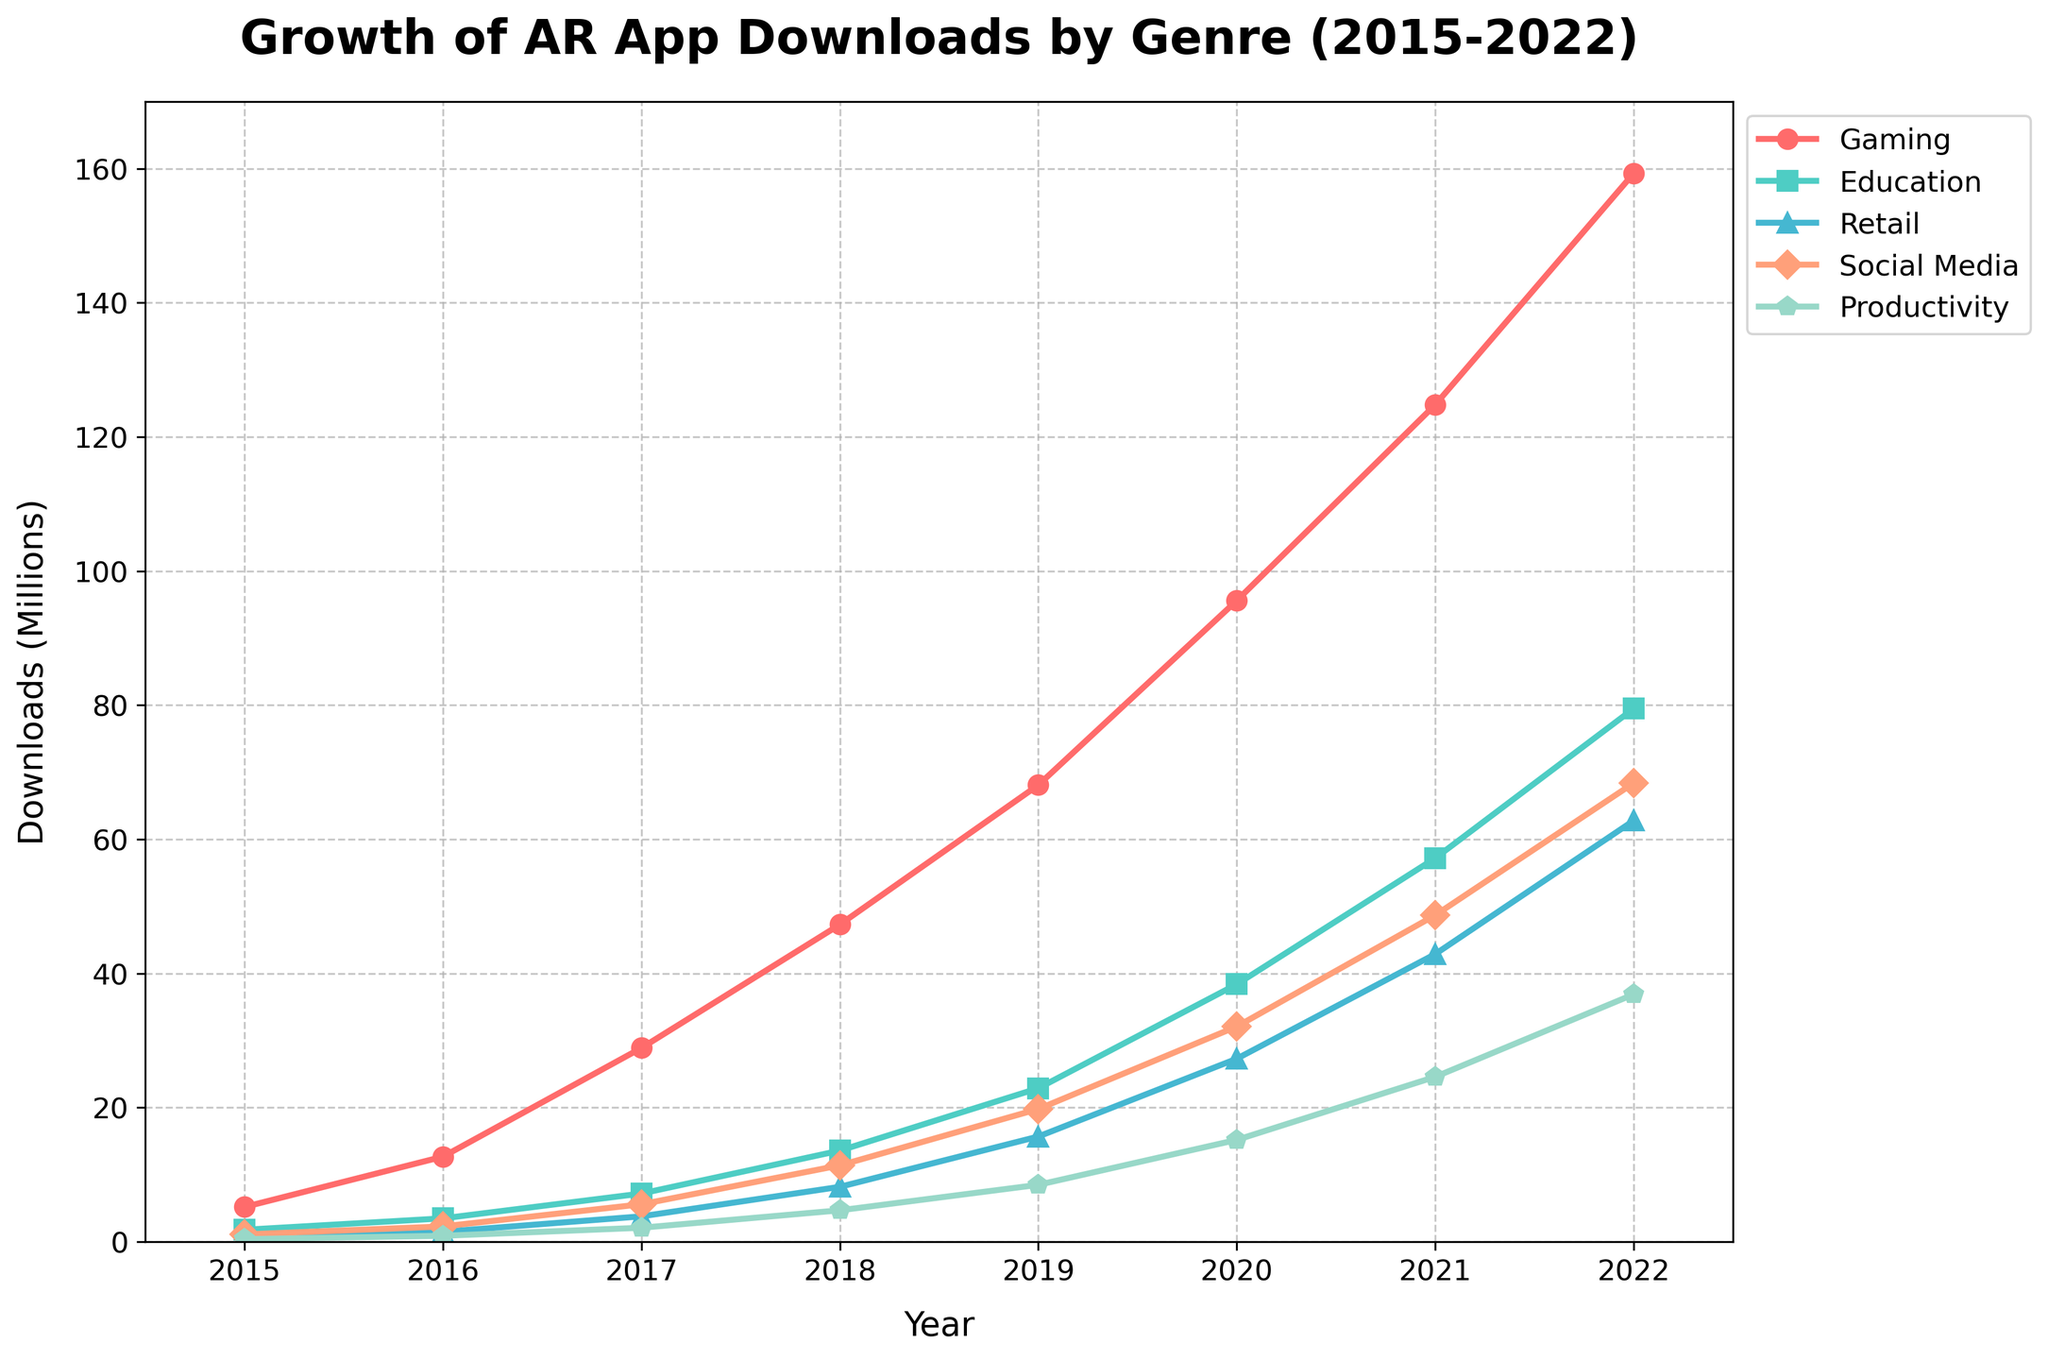What's the total number of downloads for all genres in 2017? To find the total number of downloads for all genres in 2017, sum the values for Gaming, Education, Retail, Social Media, and Productivity. So, 28.9 + 7.2 + 3.8 + 5.6 + 2.1 = 47.6 million.
Answer: 47.6 million Which genre saw the highest downloads in 2022? Examine the values for each genre in 2022: Gaming (159.3), Education (79.5), Retail (62.8), Social Media (68.4), and Productivity (36.9). The highest value is Gaming with 159.3 million downloads.
Answer: Gaming In which year did Social Media surpass 30 million downloads? Analyze the trend line of Social Media and find the year it first surpasses 30 million. It occurs in 2020 where it reaches 32.1 million downloads.
Answer: 2020 How much more did Gaming downloads grow compared to Retail from 2015 to 2022? Calculate the difference in growth for both genres from 2015 to 2022. For Gaming: 159.3 - 5.2 = 154.1. For Retail: 62.8 - 0.7 = 62.1. The growth difference is 154.1 - 62.1 = 92 million.
Answer: 92 million What is the average annual growth of downloads for the Education genre between 2015 and 2022? Determine the total increase from 2015 to 2022: 79.5 - 1.8 = 77.7 million. Then, average it over the 7 years: 77.7 / 7 ≈ 11.1 million per year.
Answer: 11.1 million per year Which two genres had the highest combined downloads in 2021? Summarize the downloads for each possible pair in 2021, then identify the highest sum: Gaming (124.8), Education (57.2), Retail (42.9), Social Media (48.7), Productivity (24.6). The two highest combined are Gaming and Education: 124.8 + 57.2 = 182 million.
Answer: Gaming and Education Between 2018 and 2020, which genre shows the smallest increase in downloads? Calculate the difference in downloads between 2018 and 2020 for each genre. Gaming: 95.6 - 47.3 = 48.3, Education: 38.4 - 13.6 = 24.8, Retail: 27.3 - 8.2 = 19.1, Social Media: 32.1 - 11.4 = 20.7, Productivity: 15.2 - 4.7 = 10.5. The smallest increase is for Productivity: 10.5 million.
Answer: Productivity Compare the growth rates of Social Media and Productivity from 2017 to 2019. Which one grew faster? Compute the growth rates: (2019 value - 2017 value) / 2017 value. For Social Media: (19.8 - 5.6) / 5.6 ≈ 2.54 or 254%. For Productivity: (8.5 - 2.1) / 2.1 ≈ 3.05 or 305%. Productivity grew faster.
Answer: Productivity What was the ratio of Gaming downloads to Productivity downloads in 2016? Divide the downloads of Gaming by Productivity in 2016. For Gaming: 12.7, for Productivity: 0.9. So, 12.7 / 0.9 ≈ 14.11.
Answer: 14.11 How did the trend of Retail downloads change from 2015 to 2022? Observe the Retail trend line from 2015 (0.7) to 2022 (62.8). The trend shows a consistent increase every year, with a significant rise especially after 2017.
Answer: Consistent increase 